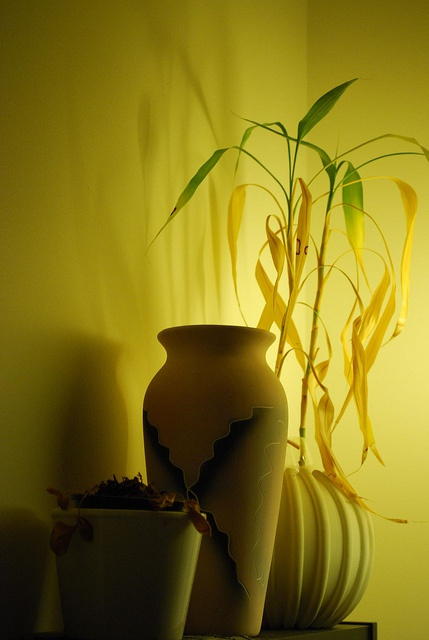Describe the objects in this image and their specific colors. I can see potted plant in darkgreen, khaki, gold, and olive tones, vase in darkgreen, black, and olive tones, potted plant in darkgreen, black, and olive tones, and vase in darkgreen, olive, and black tones in this image. 